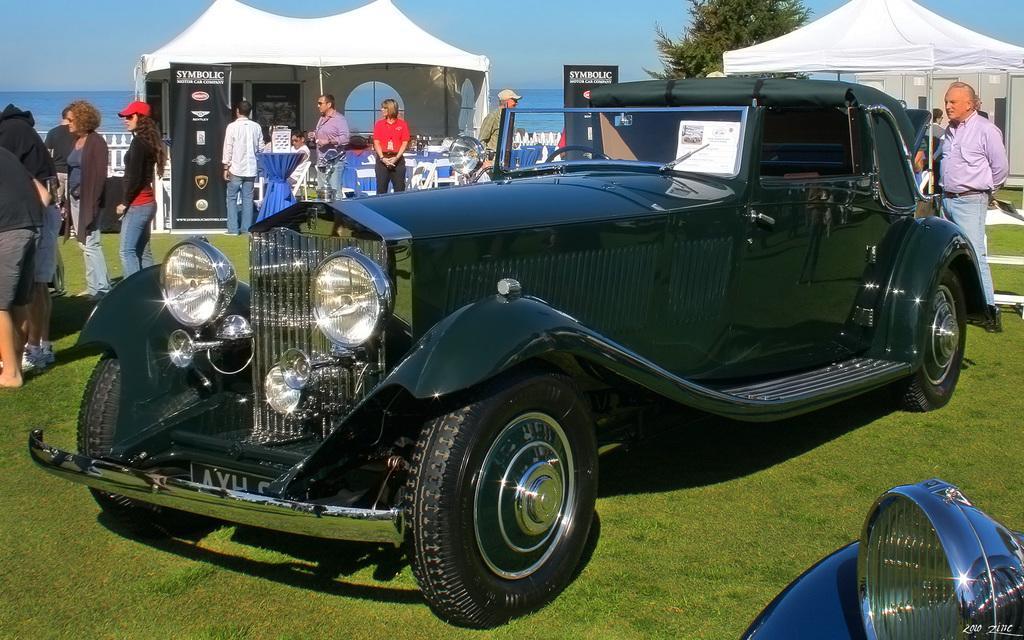Can you describe this image briefly? In the image there is a car and in the foreground, it is is kept on a grassland and around the car there are many people, there are two tents and under the tents there are few people, there are banners behind the car and in the background there is a water surface and on the right side there is a tree. 